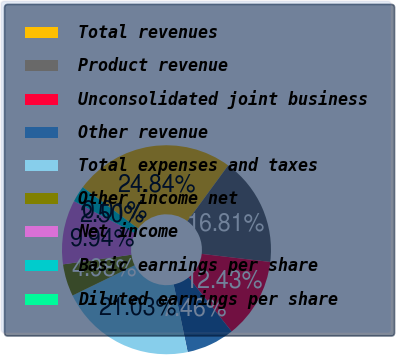Convert chart to OTSL. <chart><loc_0><loc_0><loc_500><loc_500><pie_chart><fcel>Total revenues<fcel>Product revenue<fcel>Unconsolidated joint business<fcel>Other revenue<fcel>Total expenses and taxes<fcel>Other income net<fcel>Net income<fcel>Basic earnings per share<fcel>Diluted earnings per share<nl><fcel>24.84%<fcel>16.81%<fcel>12.43%<fcel>7.46%<fcel>21.03%<fcel>4.98%<fcel>9.94%<fcel>2.5%<fcel>0.01%<nl></chart> 